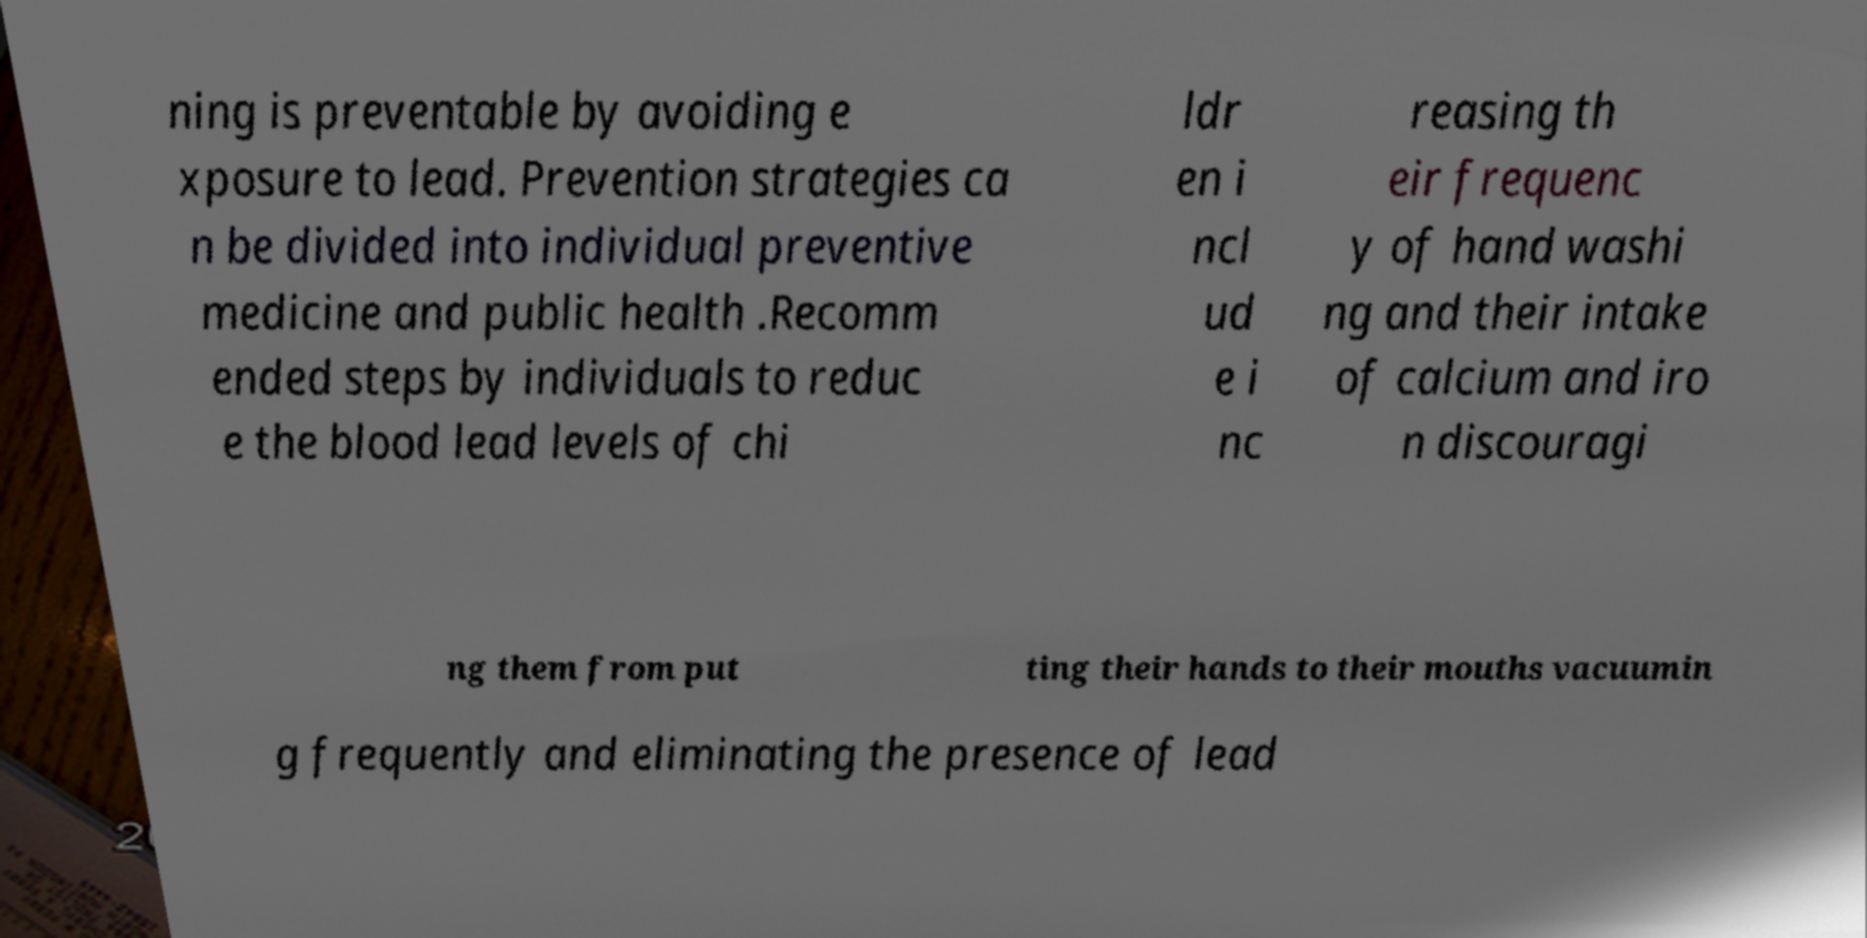For documentation purposes, I need the text within this image transcribed. Could you provide that? ning is preventable by avoiding e xposure to lead. Prevention strategies ca n be divided into individual preventive medicine and public health .Recomm ended steps by individuals to reduc e the blood lead levels of chi ldr en i ncl ud e i nc reasing th eir frequenc y of hand washi ng and their intake of calcium and iro n discouragi ng them from put ting their hands to their mouths vacuumin g frequently and eliminating the presence of lead 